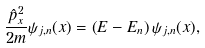<formula> <loc_0><loc_0><loc_500><loc_500>\frac { \hat { p } _ { x } ^ { 2 } } { 2 m } { \psi } _ { j , n } ( x ) = \left ( E - E _ { n } \right ) { \psi } _ { j , n } ( x ) ,</formula> 